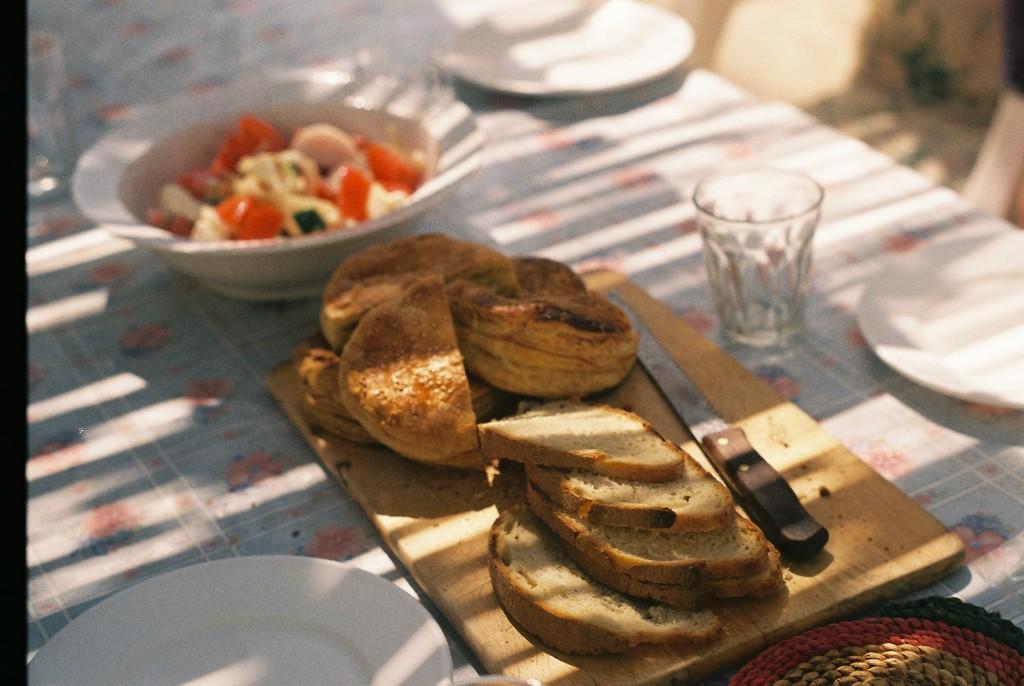Describe this image in one or two sentences. In this picture there is food and there is knife on the chopping board and there is food in the bowl. There are plates and there is a bowl, chopping board, glass and table mat on the table. At the back it looks like a chair. 